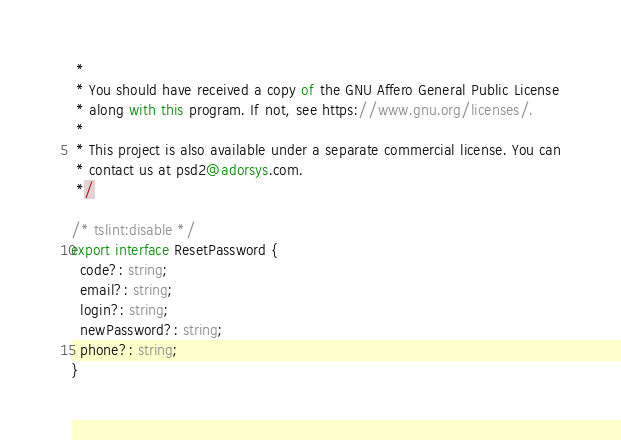Convert code to text. <code><loc_0><loc_0><loc_500><loc_500><_TypeScript_> *
 * You should have received a copy of the GNU Affero General Public License
 * along with this program. If not, see https://www.gnu.org/licenses/.
 *
 * This project is also available under a separate commercial license. You can
 * contact us at psd2@adorsys.com.
 */

/* tslint:disable */
export interface ResetPassword {
  code?: string;
  email?: string;
  login?: string;
  newPassword?: string;
  phone?: string;
}
</code> 